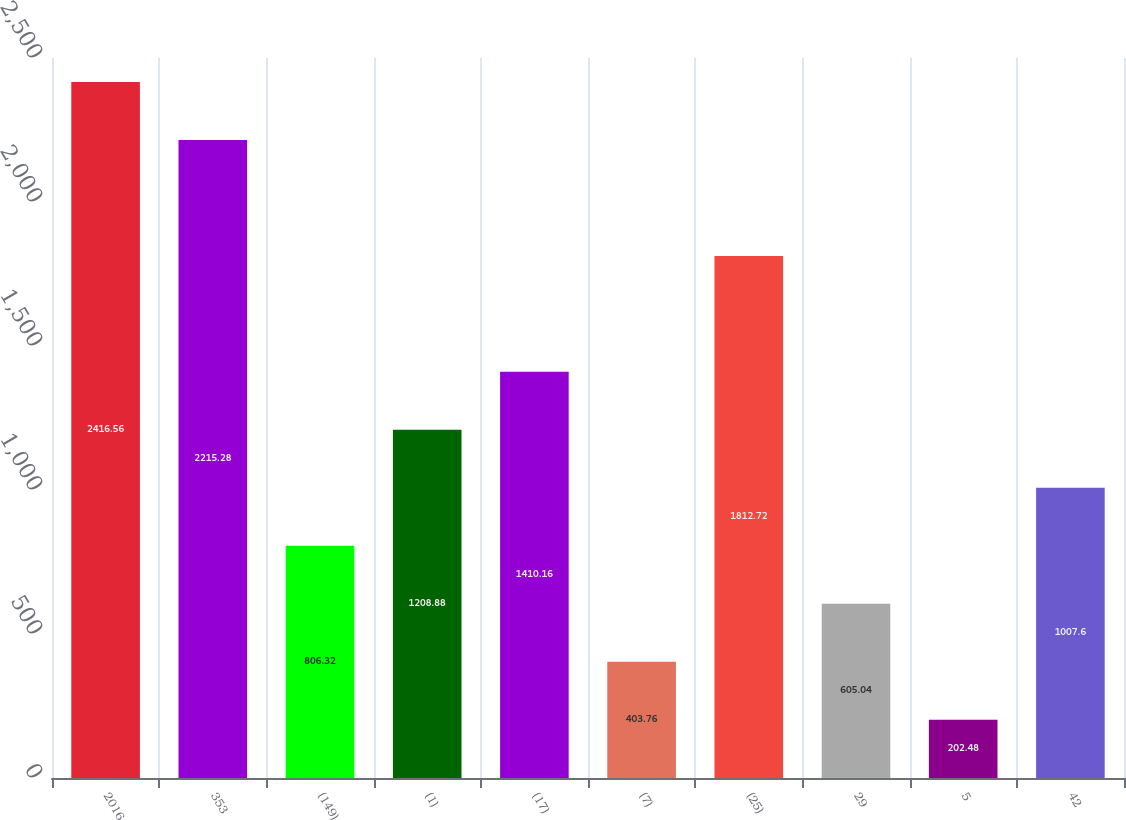Convert chart. <chart><loc_0><loc_0><loc_500><loc_500><bar_chart><fcel>2016<fcel>353<fcel>(149)<fcel>(1)<fcel>(17)<fcel>(7)<fcel>(25)<fcel>29<fcel>5<fcel>42<nl><fcel>2416.56<fcel>2215.28<fcel>806.32<fcel>1208.88<fcel>1410.16<fcel>403.76<fcel>1812.72<fcel>605.04<fcel>202.48<fcel>1007.6<nl></chart> 